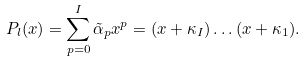Convert formula to latex. <formula><loc_0><loc_0><loc_500><loc_500>P _ { l } ( x ) = \sum _ { p = 0 } ^ { I } \tilde { \alpha } _ { p } x ^ { p } = ( x + \kappa _ { I } ) \dots ( x + \kappa _ { 1 } ) .</formula> 